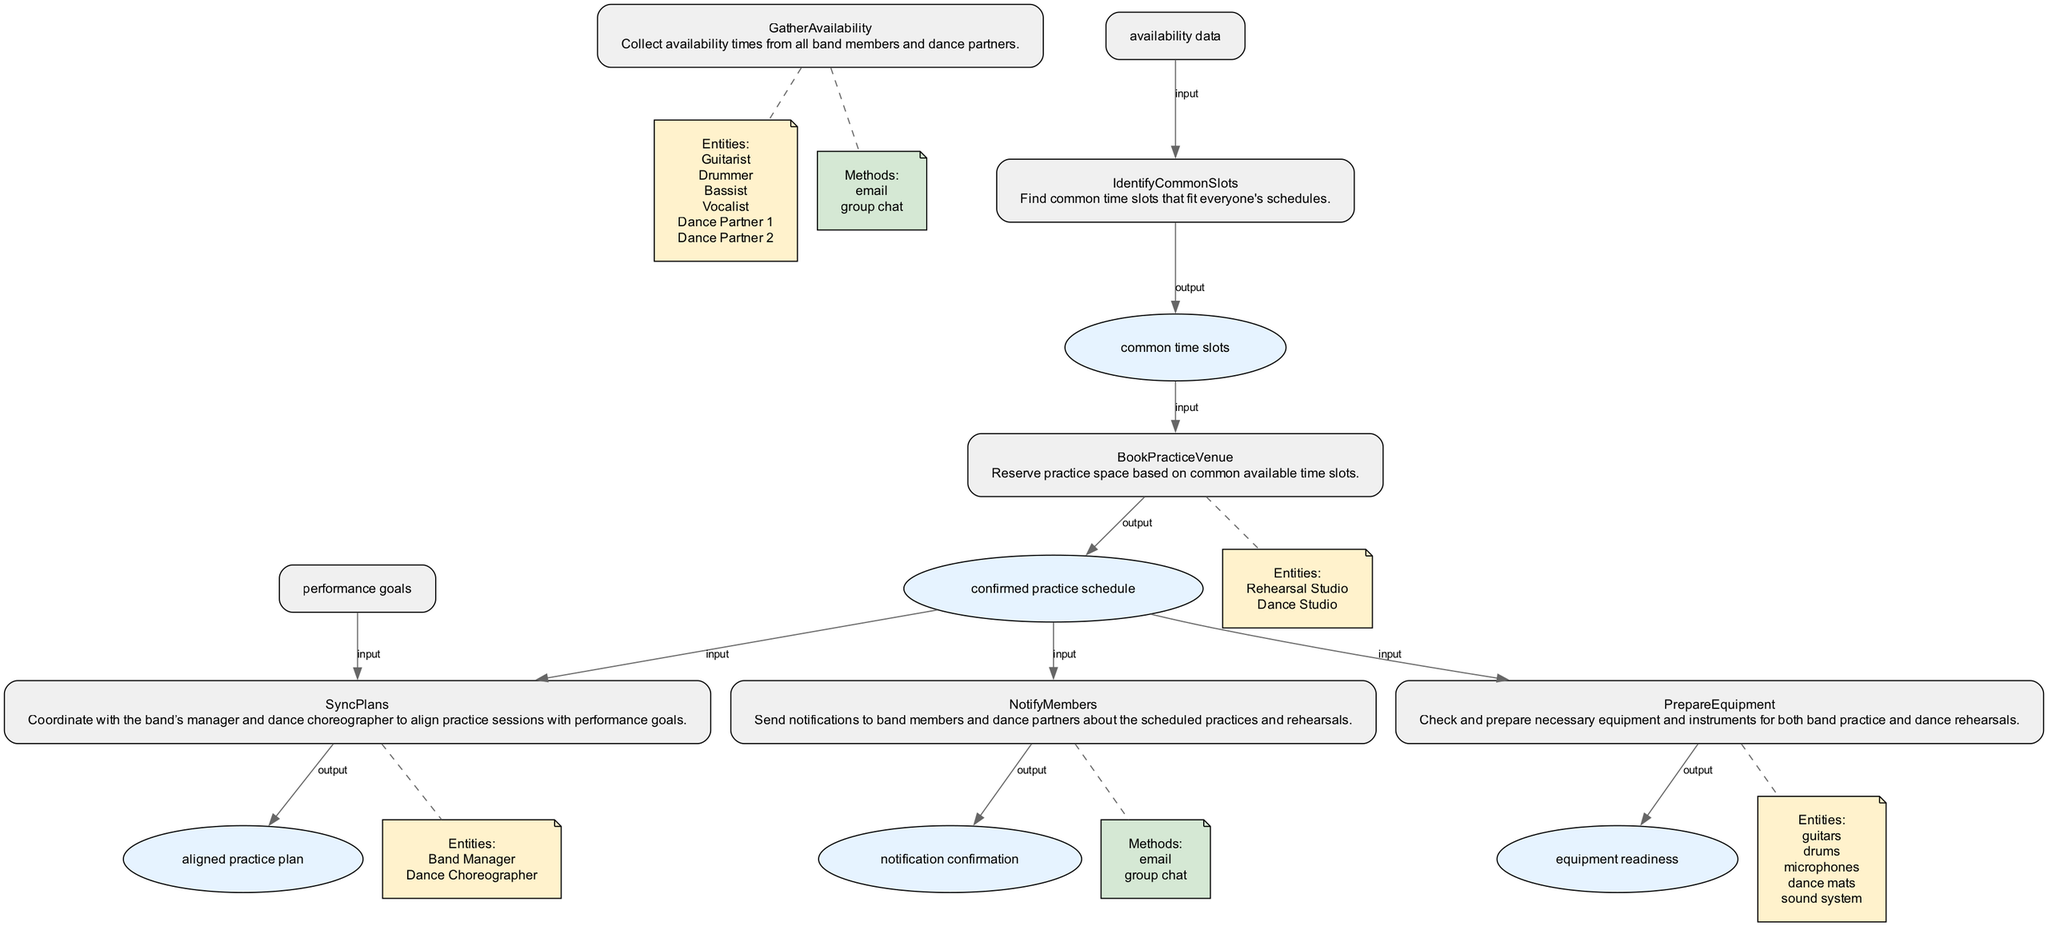What is the first step in scheduling and coordinating band practice? The first step in the diagram is "GatherAvailability," which indicates that the initial action is to collect availability times from all band members and dance partners.
Answer: GatherAvailability How many entities are involved in the "GatherAvailability" step? The "GatherAvailability" step involves six entities: Guitarist, Drummer, Bassist, Vocalist, Dance Partner 1, and Dance Partner 2.
Answer: Six What does the "NotifyMembers" step output? The "NotifyMembers" step outputs "notification confirmation," confirming that all members and partners have been informed of the schedule.
Answer: notification confirmation Which method is used to send notifications in the "NotifyMembers" step? The "NotifyMembers" step uses methods such as email and group chat to send notifications to individuals.
Answer: email, group chat What is the input for the "SyncPlans" step? The input for the "SyncPlans" step consists of two items: "performance goals" and "confirmed practice schedule," representing the necessary information to align plans.
Answer: performance goals, confirmed practice schedule How many steps involve preparing equipment? Only one step, "PrepareEquipment," involves preparing necessary equipment and instruments for both band practice and dance rehearsals.
Answer: One What is the common sequence of actions from "IdentifyCommonSlots" to "BookPracticeVenue"? After "IdentifyCommonSlots," the next step is "BookPracticeVenue," demonstrating a linear flow where the identification of common time slots leads directly to the reservation of practice space.
Answer: IdentifyCommonSlots to BookPracticeVenue What entities are involved in the "SyncPlans" step? The entities involved in the "SyncPlans" step are the Band Manager and the Dance Choreographer, highlighting those responsible for overseeing plan alignment.
Answer: Band Manager, Dance Choreographer What is the output of the "BookPracticeVenue" step? The output of the "BookPracticeVenue" step is "confirmed practice schedule," indicating that the practice time has been successfully reserved.
Answer: confirmed practice schedule 